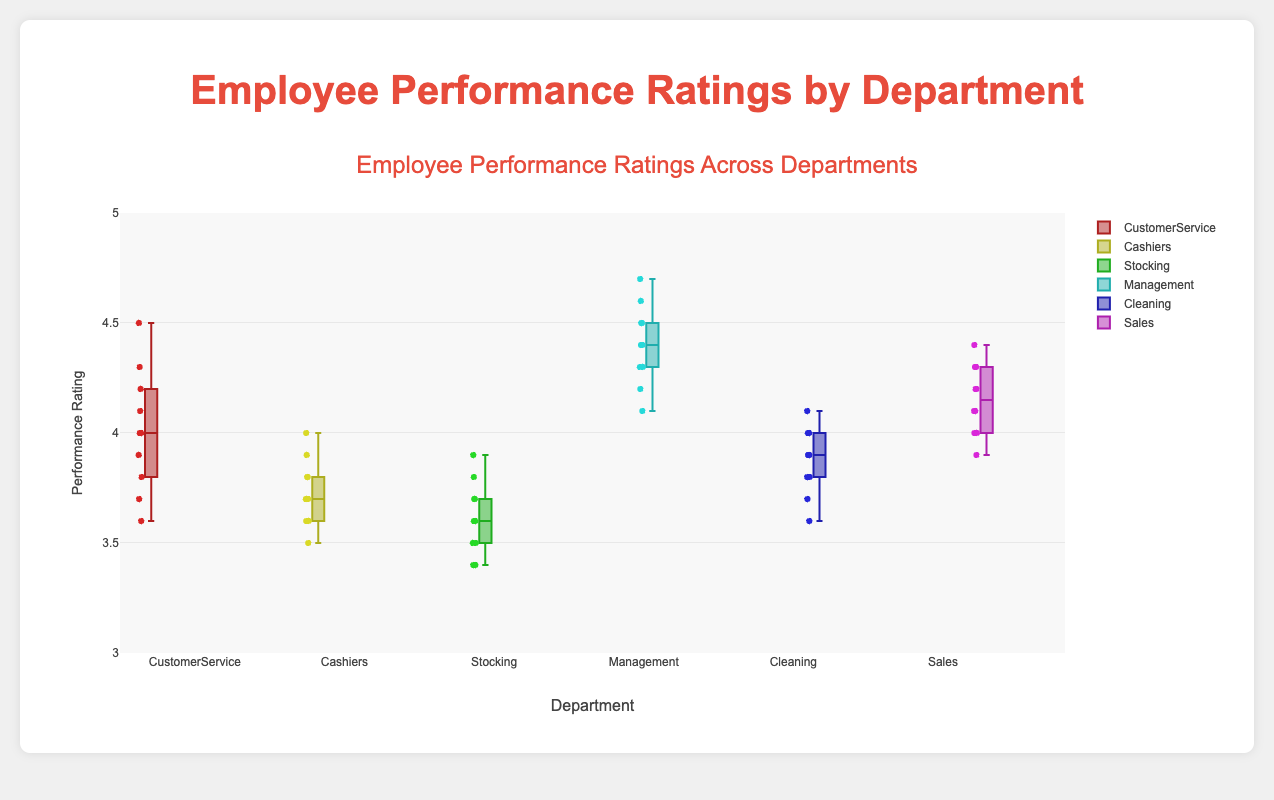What's the title of the figure? The title is located at the top of the figure in larger, bold text.
Answer: Employee Performance Ratings by Department What are the labels of the y-axis and x-axis? The y-axis label is "Performance Rating" and it's found on the left side of the plot. The x-axis label is "Department" and it's located at the bottom of the plot.
Answer: Performance Rating and Department Which department has the highest median performance rating? The median is represented by the line within each box. The box representing the Management department has the highest median line.
Answer: Management What is the range of performance ratings for the Cleaning department? The range of the box plot is represented by the length from the bottom whisker to the top whisker. For Cleaning, it ranges from 3.6 to 4.1.
Answer: 3.6 to 4.1 Which department has the highest maximum performance rating? The highest maximum performance rating is represented by the top whisker of the box plot. This is seen in the Management department.
Answer: Management Which department shows the least interquartile range (IQR) for performance ratings? The IQR is the distance between the lower quartile (bottom of the box) and the upper quartile (top of the box). The Cashiers department shows the least IQR.
Answer: Cashiers Compare the median performance rating between CustomerService and Cashiers departments. CustomerService has a median line around 4.0, whereas Cashiers has a median line around 3.7, showing a higher median in CustomerService.
Answer: CustomerService has a higher median What is the median performance rating for the Sales department? The median in a box plot is represented by the line within the box. Sales department's box plot has the median line at around 4.1.
Answer: 4.1 Which department has the largest spread of performance ratings? The spread of performance ratings is indicated by the distance from the bottom whisker to the top whisker. The Management department shows the largest spread.
Answer: Management Compare the interquartile range (IQR) of Management and Stocking departments. The IQR is the distance between the lower quartile and the upper quartile. Management has a larger box indicating a larger IQR compared to Stocking.
Answer: Management has a larger IQR 